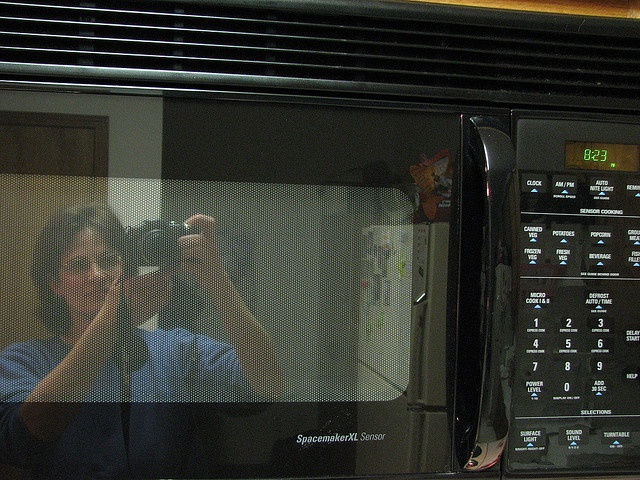Describe the objects in this image and their specific colors. I can see microwave in black, gray, darkgreen, and darkgray tones and people in black, gray, darkgreen, and darkgray tones in this image. 